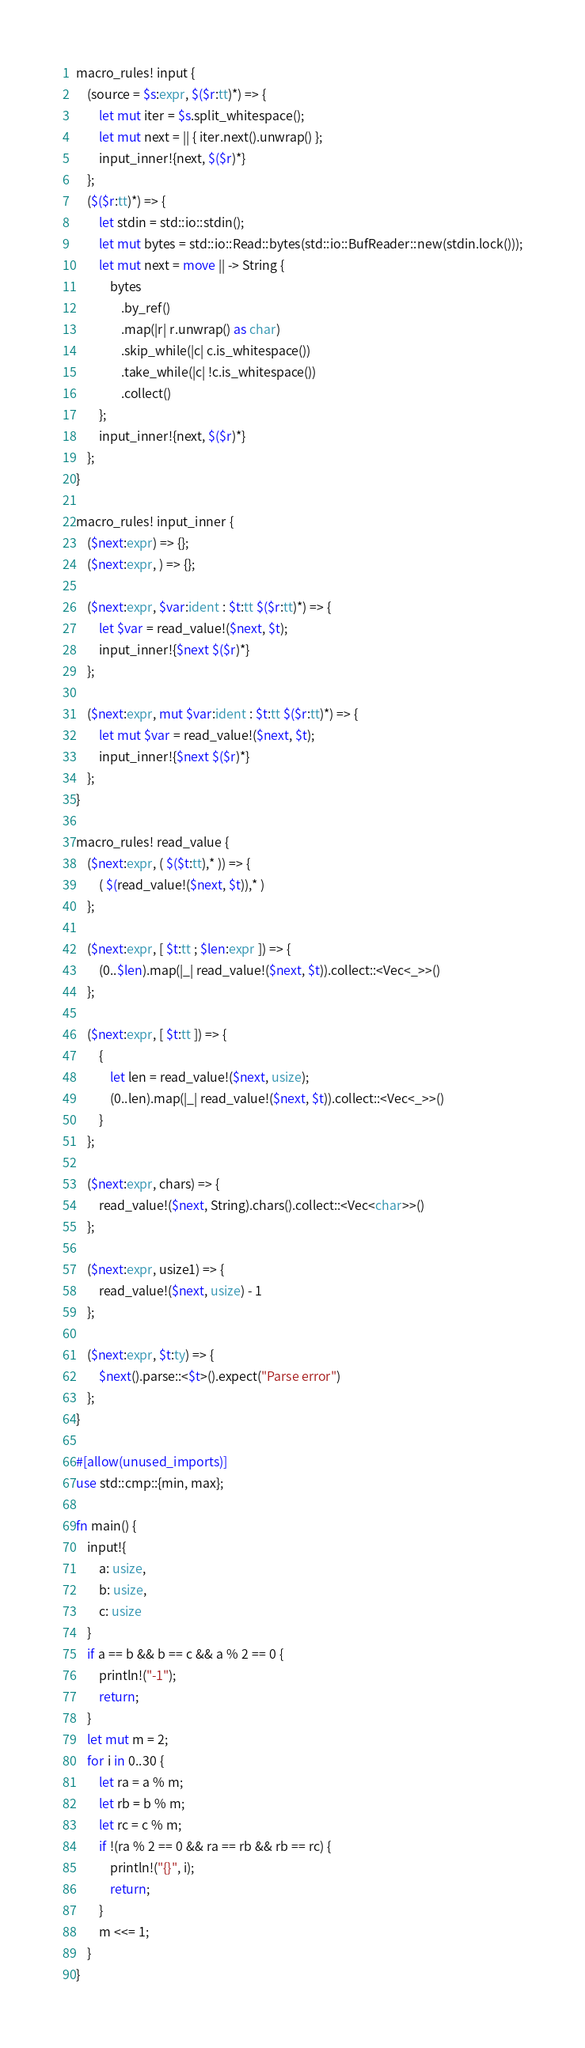<code> <loc_0><loc_0><loc_500><loc_500><_Rust_>macro_rules! input {
    (source = $s:expr, $($r:tt)*) => {
        let mut iter = $s.split_whitespace();
        let mut next = || { iter.next().unwrap() };
        input_inner!{next, $($r)*}
    };
    ($($r:tt)*) => {
        let stdin = std::io::stdin();
        let mut bytes = std::io::Read::bytes(std::io::BufReader::new(stdin.lock()));
        let mut next = move || -> String {
            bytes
                .by_ref()
                .map(|r| r.unwrap() as char)
                .skip_while(|c| c.is_whitespace())
                .take_while(|c| !c.is_whitespace())
                .collect()
        };
        input_inner!{next, $($r)*}
    };
}

macro_rules! input_inner {
    ($next:expr) => {};
    ($next:expr, ) => {};

    ($next:expr, $var:ident : $t:tt $($r:tt)*) => {
        let $var = read_value!($next, $t);
        input_inner!{$next $($r)*}
    };

    ($next:expr, mut $var:ident : $t:tt $($r:tt)*) => {
        let mut $var = read_value!($next, $t);
        input_inner!{$next $($r)*}
    };
}

macro_rules! read_value {
    ($next:expr, ( $($t:tt),* )) => {
        ( $(read_value!($next, $t)),* )
    };

    ($next:expr, [ $t:tt ; $len:expr ]) => {
        (0..$len).map(|_| read_value!($next, $t)).collect::<Vec<_>>()
    };

    ($next:expr, [ $t:tt ]) => {
        {
            let len = read_value!($next, usize);
            (0..len).map(|_| read_value!($next, $t)).collect::<Vec<_>>()
        }
    };

    ($next:expr, chars) => {
        read_value!($next, String).chars().collect::<Vec<char>>()
    };

    ($next:expr, usize1) => {
        read_value!($next, usize) - 1
    };

    ($next:expr, $t:ty) => {
        $next().parse::<$t>().expect("Parse error")
    };
}

#[allow(unused_imports)]
use std::cmp::{min, max};

fn main() {
    input!{
        a: usize,
        b: usize,
        c: usize
    }
    if a == b && b == c && a % 2 == 0 {
        println!("-1");
        return;
    }
    let mut m = 2;
    for i in 0..30 {
        let ra = a % m;
        let rb = b % m;
        let rc = c % m;
        if !(ra % 2 == 0 && ra == rb && rb == rc) {
            println!("{}", i);
            return;
        }
        m <<= 1;
    }
}
</code> 